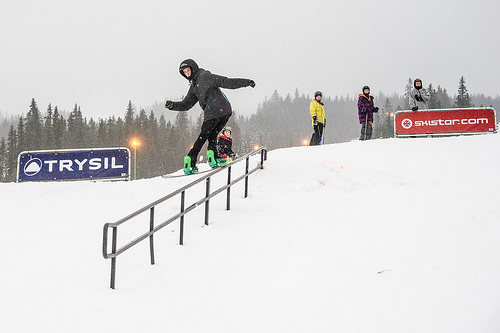Is the man to the left of the people wearing a cap? No, the man to the left of the people is not wearing a cap. 